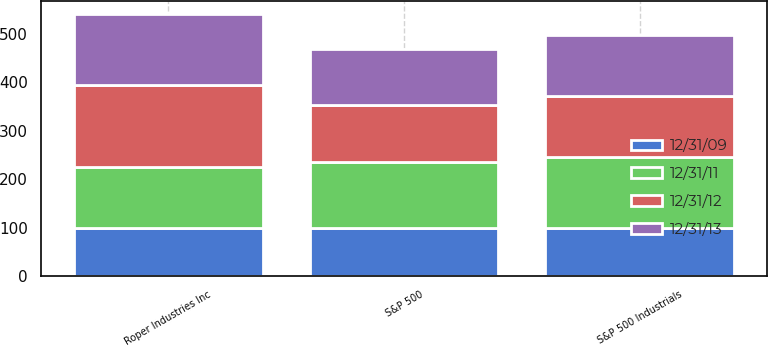Convert chart to OTSL. <chart><loc_0><loc_0><loc_500><loc_500><stacked_bar_chart><ecel><fcel>Roper Industries Inc<fcel>S&P 500<fcel>S&P 500 Industrials<nl><fcel>12/31/09<fcel>100<fcel>100<fcel>100<nl><fcel>12/31/13<fcel>146.9<fcel>115.06<fcel>126.73<nl><fcel>12/31/12<fcel>167.89<fcel>117.49<fcel>125.98<nl><fcel>12/31/11<fcel>125.98<fcel>136.3<fcel>145.32<nl></chart> 